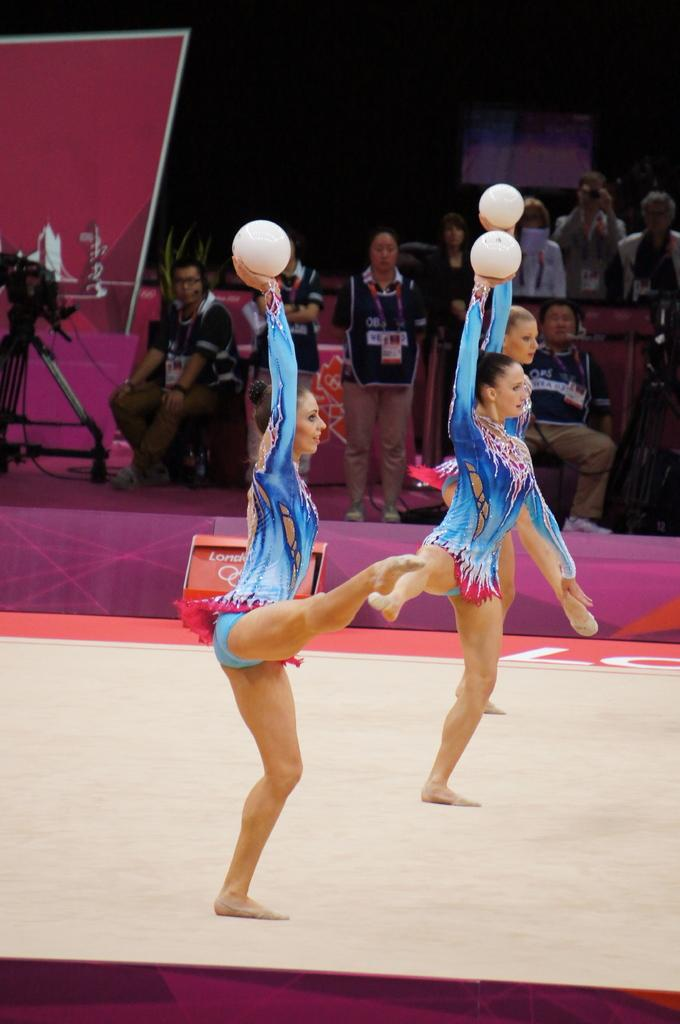What activity are the three ladies in the image engaged in? A: The three ladies are performing gymnastics in the image. On what surface are the gymnastics being performed? The gymnastics are being performed on a floor. What can be observed in the background of the image? In the background of the image, there are people sitting and standing. What type of place is being blown up in the image? There is no place being blown up in the image; it features three ladies performing gymnastics on a floor with people sitting and standing in the background. 